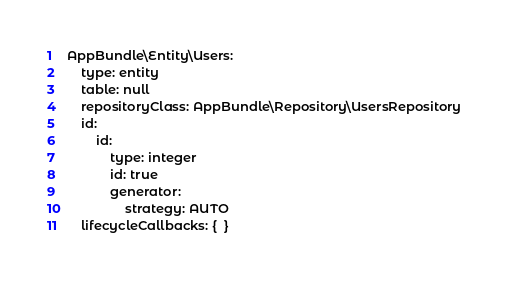<code> <loc_0><loc_0><loc_500><loc_500><_YAML_>AppBundle\Entity\Users:
    type: entity
    table: null
    repositoryClass: AppBundle\Repository\UsersRepository
    id:
        id:
            type: integer
            id: true
            generator:
                strategy: AUTO
    lifecycleCallbacks: {  }</code> 